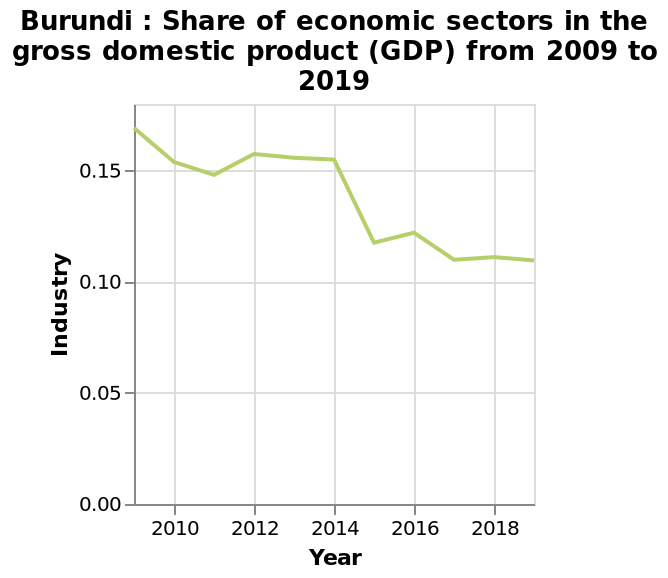<image>
Offer a thorough analysis of the image. There has been a steady decrease in share of economic sectors in GDP over ten years, 2009 - 2019. However there were two periods where this rose briefly before decreasing, in 2011 and 2015. 2014 saw the greatest decrease. please summary the statistics and relations of the chart 2019 was the lowest gdp 2009 was the lighest gdp and its a eratic line of ups and downs. Describe the following image in detail This line plot is named Burundi : Share of economic sectors in the gross domestic product (GDP) from 2009 to 2019. There is a scale with a minimum of 0.00 and a maximum of 0.15 on the y-axis, labeled Industry. A linear scale from 2010 to 2018 can be seen along the x-axis, labeled Year. What was the lowest GDP in 2019? The lowest GDP in 2019 was recorded in that year. 